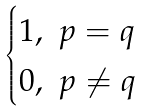Convert formula to latex. <formula><loc_0><loc_0><loc_500><loc_500>\begin{cases} 1 , \ p = q \\ 0 , \ p \neq q \end{cases}</formula> 